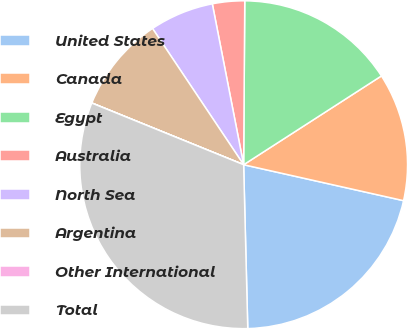Convert chart to OTSL. <chart><loc_0><loc_0><loc_500><loc_500><pie_chart><fcel>United States<fcel>Canada<fcel>Egypt<fcel>Australia<fcel>North Sea<fcel>Argentina<fcel>Other International<fcel>Total<nl><fcel>21.08%<fcel>12.63%<fcel>15.78%<fcel>3.17%<fcel>6.32%<fcel>9.47%<fcel>0.01%<fcel>31.54%<nl></chart> 